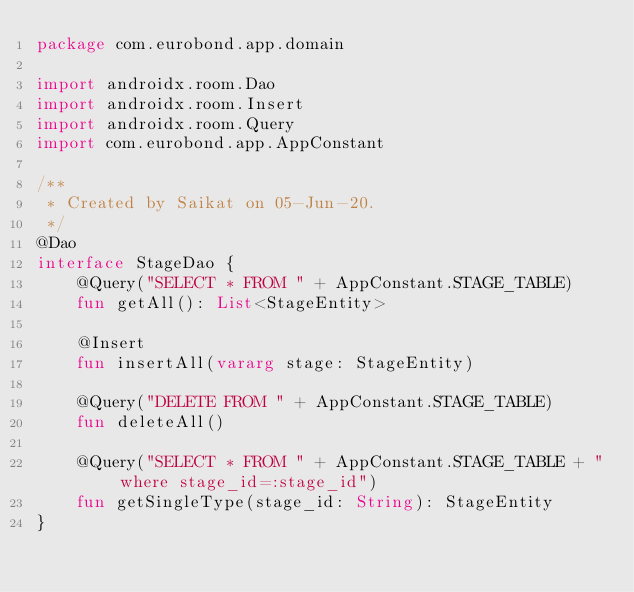Convert code to text. <code><loc_0><loc_0><loc_500><loc_500><_Kotlin_>package com.eurobond.app.domain

import androidx.room.Dao
import androidx.room.Insert
import androidx.room.Query
import com.eurobond.app.AppConstant

/**
 * Created by Saikat on 05-Jun-20.
 */
@Dao
interface StageDao {
    @Query("SELECT * FROM " + AppConstant.STAGE_TABLE)
    fun getAll(): List<StageEntity>

    @Insert
    fun insertAll(vararg stage: StageEntity)

    @Query("DELETE FROM " + AppConstant.STAGE_TABLE)
    fun deleteAll()

    @Query("SELECT * FROM " + AppConstant.STAGE_TABLE + " where stage_id=:stage_id")
    fun getSingleType(stage_id: String): StageEntity
}</code> 